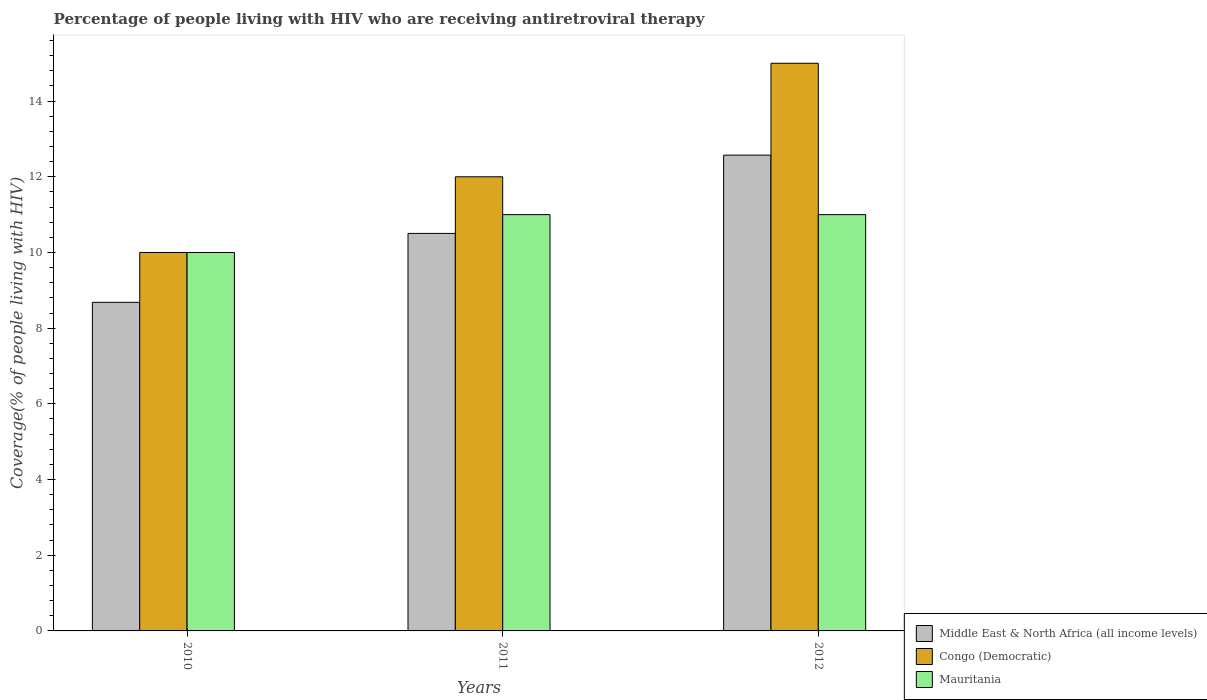Are the number of bars on each tick of the X-axis equal?
Your answer should be very brief. Yes. How many bars are there on the 1st tick from the left?
Make the answer very short. 3. How many bars are there on the 1st tick from the right?
Your response must be concise. 3. What is the label of the 2nd group of bars from the left?
Make the answer very short. 2011. In how many cases, is the number of bars for a given year not equal to the number of legend labels?
Your response must be concise. 0. What is the percentage of the HIV infected people who are receiving antiretroviral therapy in Middle East & North Africa (all income levels) in 2011?
Offer a terse response. 10.5. Across all years, what is the maximum percentage of the HIV infected people who are receiving antiretroviral therapy in Congo (Democratic)?
Make the answer very short. 15. Across all years, what is the minimum percentage of the HIV infected people who are receiving antiretroviral therapy in Middle East & North Africa (all income levels)?
Your response must be concise. 8.68. In which year was the percentage of the HIV infected people who are receiving antiretroviral therapy in Middle East & North Africa (all income levels) maximum?
Provide a short and direct response. 2012. What is the total percentage of the HIV infected people who are receiving antiretroviral therapy in Middle East & North Africa (all income levels) in the graph?
Keep it short and to the point. 31.76. What is the difference between the percentage of the HIV infected people who are receiving antiretroviral therapy in Middle East & North Africa (all income levels) in 2011 and the percentage of the HIV infected people who are receiving antiretroviral therapy in Congo (Democratic) in 2010?
Make the answer very short. 0.5. What is the average percentage of the HIV infected people who are receiving antiretroviral therapy in Congo (Democratic) per year?
Ensure brevity in your answer.  12.33. In the year 2011, what is the difference between the percentage of the HIV infected people who are receiving antiretroviral therapy in Congo (Democratic) and percentage of the HIV infected people who are receiving antiretroviral therapy in Mauritania?
Your response must be concise. 1. In how many years, is the percentage of the HIV infected people who are receiving antiretroviral therapy in Congo (Democratic) greater than 10.4 %?
Your response must be concise. 2. What is the ratio of the percentage of the HIV infected people who are receiving antiretroviral therapy in Middle East & North Africa (all income levels) in 2010 to that in 2011?
Your answer should be compact. 0.83. Is the percentage of the HIV infected people who are receiving antiretroviral therapy in Middle East & North Africa (all income levels) in 2010 less than that in 2012?
Make the answer very short. Yes. What is the difference between the highest and the lowest percentage of the HIV infected people who are receiving antiretroviral therapy in Mauritania?
Keep it short and to the point. 1. In how many years, is the percentage of the HIV infected people who are receiving antiretroviral therapy in Mauritania greater than the average percentage of the HIV infected people who are receiving antiretroviral therapy in Mauritania taken over all years?
Your response must be concise. 2. Is the sum of the percentage of the HIV infected people who are receiving antiretroviral therapy in Middle East & North Africa (all income levels) in 2010 and 2012 greater than the maximum percentage of the HIV infected people who are receiving antiretroviral therapy in Congo (Democratic) across all years?
Your answer should be very brief. Yes. What does the 1st bar from the left in 2010 represents?
Your answer should be very brief. Middle East & North Africa (all income levels). What does the 3rd bar from the right in 2010 represents?
Offer a terse response. Middle East & North Africa (all income levels). Are all the bars in the graph horizontal?
Your answer should be very brief. No. How many years are there in the graph?
Your answer should be compact. 3. What is the difference between two consecutive major ticks on the Y-axis?
Your answer should be compact. 2. Does the graph contain grids?
Ensure brevity in your answer.  No. Where does the legend appear in the graph?
Make the answer very short. Bottom right. How are the legend labels stacked?
Keep it short and to the point. Vertical. What is the title of the graph?
Your answer should be very brief. Percentage of people living with HIV who are receiving antiretroviral therapy. Does "Iceland" appear as one of the legend labels in the graph?
Make the answer very short. No. What is the label or title of the X-axis?
Keep it short and to the point. Years. What is the label or title of the Y-axis?
Your answer should be very brief. Coverage(% of people living with HIV). What is the Coverage(% of people living with HIV) of Middle East & North Africa (all income levels) in 2010?
Give a very brief answer. 8.68. What is the Coverage(% of people living with HIV) in Congo (Democratic) in 2010?
Keep it short and to the point. 10. What is the Coverage(% of people living with HIV) in Middle East & North Africa (all income levels) in 2011?
Ensure brevity in your answer.  10.5. What is the Coverage(% of people living with HIV) of Mauritania in 2011?
Give a very brief answer. 11. What is the Coverage(% of people living with HIV) of Middle East & North Africa (all income levels) in 2012?
Your response must be concise. 12.57. Across all years, what is the maximum Coverage(% of people living with HIV) in Middle East & North Africa (all income levels)?
Ensure brevity in your answer.  12.57. Across all years, what is the maximum Coverage(% of people living with HIV) in Congo (Democratic)?
Your response must be concise. 15. Across all years, what is the maximum Coverage(% of people living with HIV) in Mauritania?
Provide a succinct answer. 11. Across all years, what is the minimum Coverage(% of people living with HIV) of Middle East & North Africa (all income levels)?
Keep it short and to the point. 8.68. Across all years, what is the minimum Coverage(% of people living with HIV) in Congo (Democratic)?
Give a very brief answer. 10. What is the total Coverage(% of people living with HIV) of Middle East & North Africa (all income levels) in the graph?
Offer a terse response. 31.76. What is the total Coverage(% of people living with HIV) in Congo (Democratic) in the graph?
Your response must be concise. 37. What is the difference between the Coverage(% of people living with HIV) of Middle East & North Africa (all income levels) in 2010 and that in 2011?
Make the answer very short. -1.82. What is the difference between the Coverage(% of people living with HIV) of Middle East & North Africa (all income levels) in 2010 and that in 2012?
Provide a short and direct response. -3.89. What is the difference between the Coverage(% of people living with HIV) of Middle East & North Africa (all income levels) in 2011 and that in 2012?
Offer a terse response. -2.07. What is the difference between the Coverage(% of people living with HIV) of Middle East & North Africa (all income levels) in 2010 and the Coverage(% of people living with HIV) of Congo (Democratic) in 2011?
Offer a terse response. -3.32. What is the difference between the Coverage(% of people living with HIV) of Middle East & North Africa (all income levels) in 2010 and the Coverage(% of people living with HIV) of Mauritania in 2011?
Your answer should be compact. -2.32. What is the difference between the Coverage(% of people living with HIV) of Middle East & North Africa (all income levels) in 2010 and the Coverage(% of people living with HIV) of Congo (Democratic) in 2012?
Your answer should be compact. -6.32. What is the difference between the Coverage(% of people living with HIV) in Middle East & North Africa (all income levels) in 2010 and the Coverage(% of people living with HIV) in Mauritania in 2012?
Make the answer very short. -2.32. What is the difference between the Coverage(% of people living with HIV) in Middle East & North Africa (all income levels) in 2011 and the Coverage(% of people living with HIV) in Congo (Democratic) in 2012?
Provide a succinct answer. -4.5. What is the difference between the Coverage(% of people living with HIV) of Middle East & North Africa (all income levels) in 2011 and the Coverage(% of people living with HIV) of Mauritania in 2012?
Your answer should be compact. -0.5. What is the average Coverage(% of people living with HIV) of Middle East & North Africa (all income levels) per year?
Your answer should be very brief. 10.59. What is the average Coverage(% of people living with HIV) of Congo (Democratic) per year?
Ensure brevity in your answer.  12.33. What is the average Coverage(% of people living with HIV) in Mauritania per year?
Offer a terse response. 10.67. In the year 2010, what is the difference between the Coverage(% of people living with HIV) in Middle East & North Africa (all income levels) and Coverage(% of people living with HIV) in Congo (Democratic)?
Provide a short and direct response. -1.32. In the year 2010, what is the difference between the Coverage(% of people living with HIV) of Middle East & North Africa (all income levels) and Coverage(% of people living with HIV) of Mauritania?
Keep it short and to the point. -1.32. In the year 2010, what is the difference between the Coverage(% of people living with HIV) in Congo (Democratic) and Coverage(% of people living with HIV) in Mauritania?
Keep it short and to the point. 0. In the year 2011, what is the difference between the Coverage(% of people living with HIV) of Middle East & North Africa (all income levels) and Coverage(% of people living with HIV) of Congo (Democratic)?
Provide a short and direct response. -1.5. In the year 2011, what is the difference between the Coverage(% of people living with HIV) of Middle East & North Africa (all income levels) and Coverage(% of people living with HIV) of Mauritania?
Your response must be concise. -0.5. In the year 2011, what is the difference between the Coverage(% of people living with HIV) of Congo (Democratic) and Coverage(% of people living with HIV) of Mauritania?
Ensure brevity in your answer.  1. In the year 2012, what is the difference between the Coverage(% of people living with HIV) in Middle East & North Africa (all income levels) and Coverage(% of people living with HIV) in Congo (Democratic)?
Provide a short and direct response. -2.43. In the year 2012, what is the difference between the Coverage(% of people living with HIV) of Middle East & North Africa (all income levels) and Coverage(% of people living with HIV) of Mauritania?
Offer a very short reply. 1.57. In the year 2012, what is the difference between the Coverage(% of people living with HIV) in Congo (Democratic) and Coverage(% of people living with HIV) in Mauritania?
Provide a succinct answer. 4. What is the ratio of the Coverage(% of people living with HIV) of Middle East & North Africa (all income levels) in 2010 to that in 2011?
Your answer should be compact. 0.83. What is the ratio of the Coverage(% of people living with HIV) in Middle East & North Africa (all income levels) in 2010 to that in 2012?
Your response must be concise. 0.69. What is the ratio of the Coverage(% of people living with HIV) of Congo (Democratic) in 2010 to that in 2012?
Provide a short and direct response. 0.67. What is the ratio of the Coverage(% of people living with HIV) in Mauritania in 2010 to that in 2012?
Ensure brevity in your answer.  0.91. What is the ratio of the Coverage(% of people living with HIV) of Middle East & North Africa (all income levels) in 2011 to that in 2012?
Provide a succinct answer. 0.84. What is the ratio of the Coverage(% of people living with HIV) in Congo (Democratic) in 2011 to that in 2012?
Your response must be concise. 0.8. What is the ratio of the Coverage(% of people living with HIV) in Mauritania in 2011 to that in 2012?
Offer a very short reply. 1. What is the difference between the highest and the second highest Coverage(% of people living with HIV) in Middle East & North Africa (all income levels)?
Provide a short and direct response. 2.07. What is the difference between the highest and the second highest Coverage(% of people living with HIV) in Congo (Democratic)?
Your response must be concise. 3. What is the difference between the highest and the second highest Coverage(% of people living with HIV) in Mauritania?
Provide a succinct answer. 0. What is the difference between the highest and the lowest Coverage(% of people living with HIV) in Middle East & North Africa (all income levels)?
Give a very brief answer. 3.89. What is the difference between the highest and the lowest Coverage(% of people living with HIV) of Congo (Democratic)?
Provide a succinct answer. 5. What is the difference between the highest and the lowest Coverage(% of people living with HIV) of Mauritania?
Your answer should be very brief. 1. 